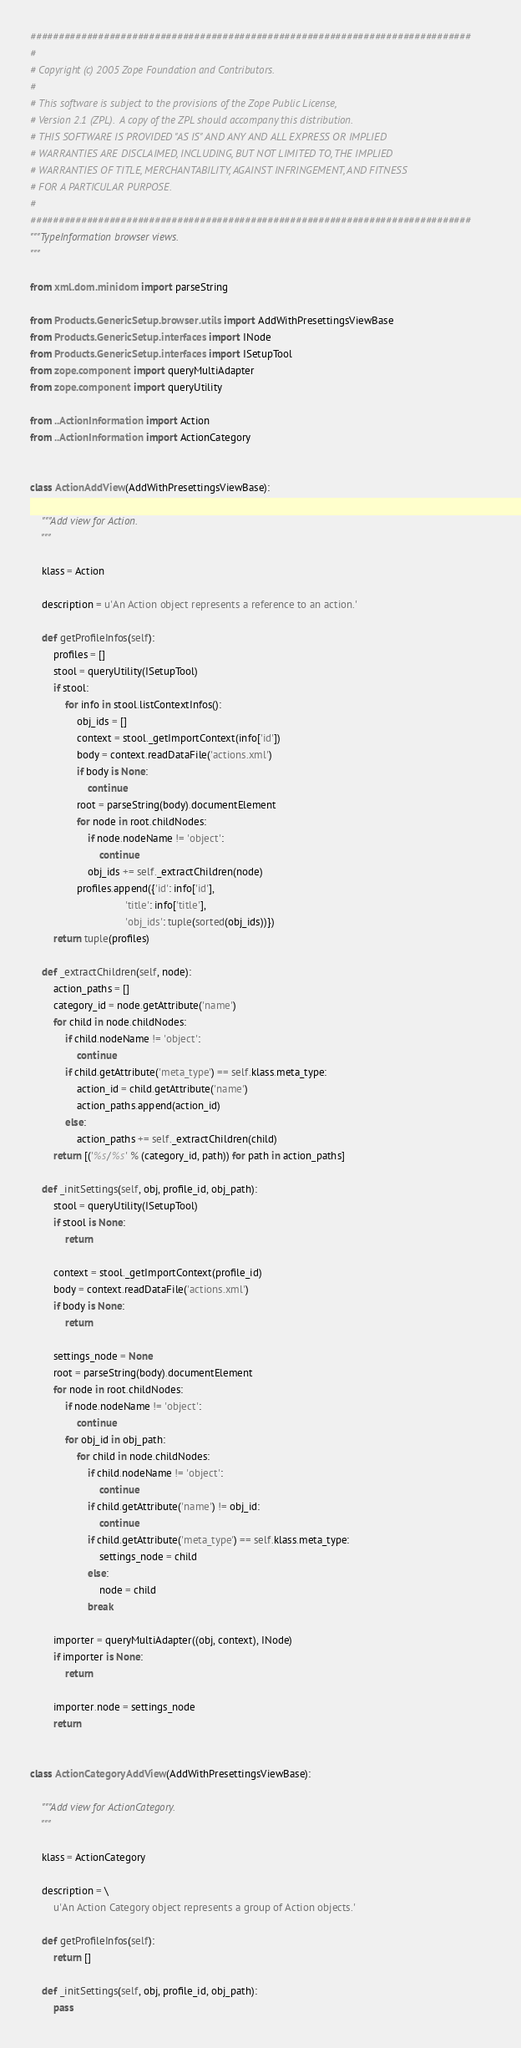<code> <loc_0><loc_0><loc_500><loc_500><_Python_>##############################################################################
#
# Copyright (c) 2005 Zope Foundation and Contributors.
#
# This software is subject to the provisions of the Zope Public License,
# Version 2.1 (ZPL).  A copy of the ZPL should accompany this distribution.
# THIS SOFTWARE IS PROVIDED "AS IS" AND ANY AND ALL EXPRESS OR IMPLIED
# WARRANTIES ARE DISCLAIMED, INCLUDING, BUT NOT LIMITED TO, THE IMPLIED
# WARRANTIES OF TITLE, MERCHANTABILITY, AGAINST INFRINGEMENT, AND FITNESS
# FOR A PARTICULAR PURPOSE.
#
##############################################################################
"""TypeInformation browser views.
"""

from xml.dom.minidom import parseString

from Products.GenericSetup.browser.utils import AddWithPresettingsViewBase
from Products.GenericSetup.interfaces import INode
from Products.GenericSetup.interfaces import ISetupTool
from zope.component import queryMultiAdapter
from zope.component import queryUtility

from ..ActionInformation import Action
from ..ActionInformation import ActionCategory


class ActionAddView(AddWithPresettingsViewBase):

    """Add view for Action.
    """

    klass = Action

    description = u'An Action object represents a reference to an action.'

    def getProfileInfos(self):
        profiles = []
        stool = queryUtility(ISetupTool)
        if stool:
            for info in stool.listContextInfos():
                obj_ids = []
                context = stool._getImportContext(info['id'])
                body = context.readDataFile('actions.xml')
                if body is None:
                    continue
                root = parseString(body).documentElement
                for node in root.childNodes:
                    if node.nodeName != 'object':
                        continue
                    obj_ids += self._extractChildren(node)
                profiles.append({'id': info['id'],
                                 'title': info['title'],
                                 'obj_ids': tuple(sorted(obj_ids))})
        return tuple(profiles)

    def _extractChildren(self, node):
        action_paths = []
        category_id = node.getAttribute('name')
        for child in node.childNodes:
            if child.nodeName != 'object':
                continue
            if child.getAttribute('meta_type') == self.klass.meta_type:
                action_id = child.getAttribute('name')
                action_paths.append(action_id)
            else:
                action_paths += self._extractChildren(child)
        return [('%s/%s' % (category_id, path)) for path in action_paths]

    def _initSettings(self, obj, profile_id, obj_path):
        stool = queryUtility(ISetupTool)
        if stool is None:
            return

        context = stool._getImportContext(profile_id)
        body = context.readDataFile('actions.xml')
        if body is None:
            return

        settings_node = None
        root = parseString(body).documentElement
        for node in root.childNodes:
            if node.nodeName != 'object':
                continue
            for obj_id in obj_path:
                for child in node.childNodes:
                    if child.nodeName != 'object':
                        continue
                    if child.getAttribute('name') != obj_id:
                        continue
                    if child.getAttribute('meta_type') == self.klass.meta_type:
                        settings_node = child
                    else:
                        node = child
                    break

        importer = queryMultiAdapter((obj, context), INode)
        if importer is None:
            return

        importer.node = settings_node
        return


class ActionCategoryAddView(AddWithPresettingsViewBase):

    """Add view for ActionCategory.
    """

    klass = ActionCategory

    description = \
        u'An Action Category object represents a group of Action objects.'

    def getProfileInfos(self):
        return []

    def _initSettings(self, obj, profile_id, obj_path):
        pass
</code> 